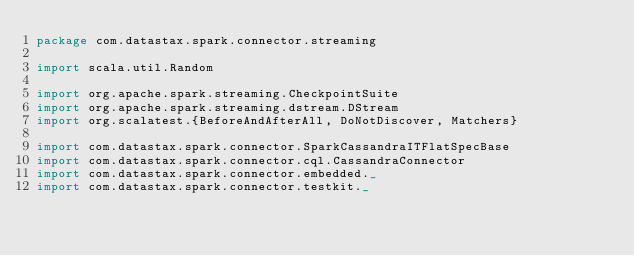Convert code to text. <code><loc_0><loc_0><loc_500><loc_500><_Scala_>package com.datastax.spark.connector.streaming

import scala.util.Random

import org.apache.spark.streaming.CheckpointSuite
import org.apache.spark.streaming.dstream.DStream
import org.scalatest.{BeforeAndAfterAll, DoNotDiscover, Matchers}

import com.datastax.spark.connector.SparkCassandraITFlatSpecBase
import com.datastax.spark.connector.cql.CassandraConnector
import com.datastax.spark.connector.embedded._
import com.datastax.spark.connector.testkit._
</code> 